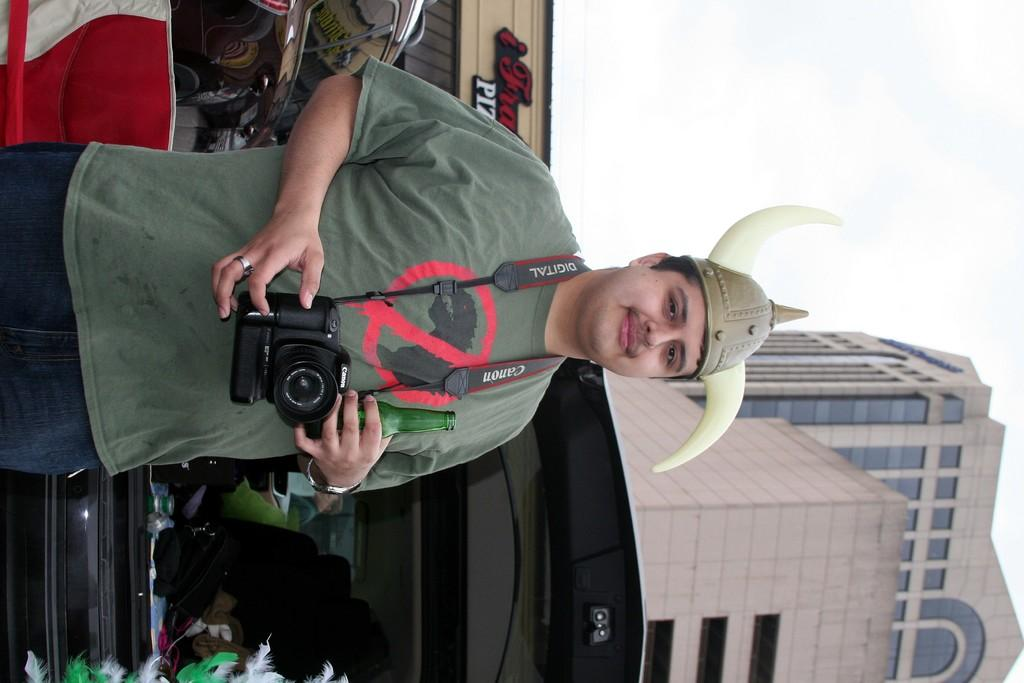How is the orientation of the image? The image is tilted. What can be seen on the left side of the image? There is a person on the left side of the image. What is located on the right side of the image? There is a building on the right side of the image. What part of the natural environment is visible in the image? The sky is visible in the top right corner of the image. What type of ball is being used in the attack in the image? There is no ball or attack present in the image; it features a person and a building with a tilted orientation. Is there a match taking place in the image? There is no match or any indication of a sporting event in the image. 